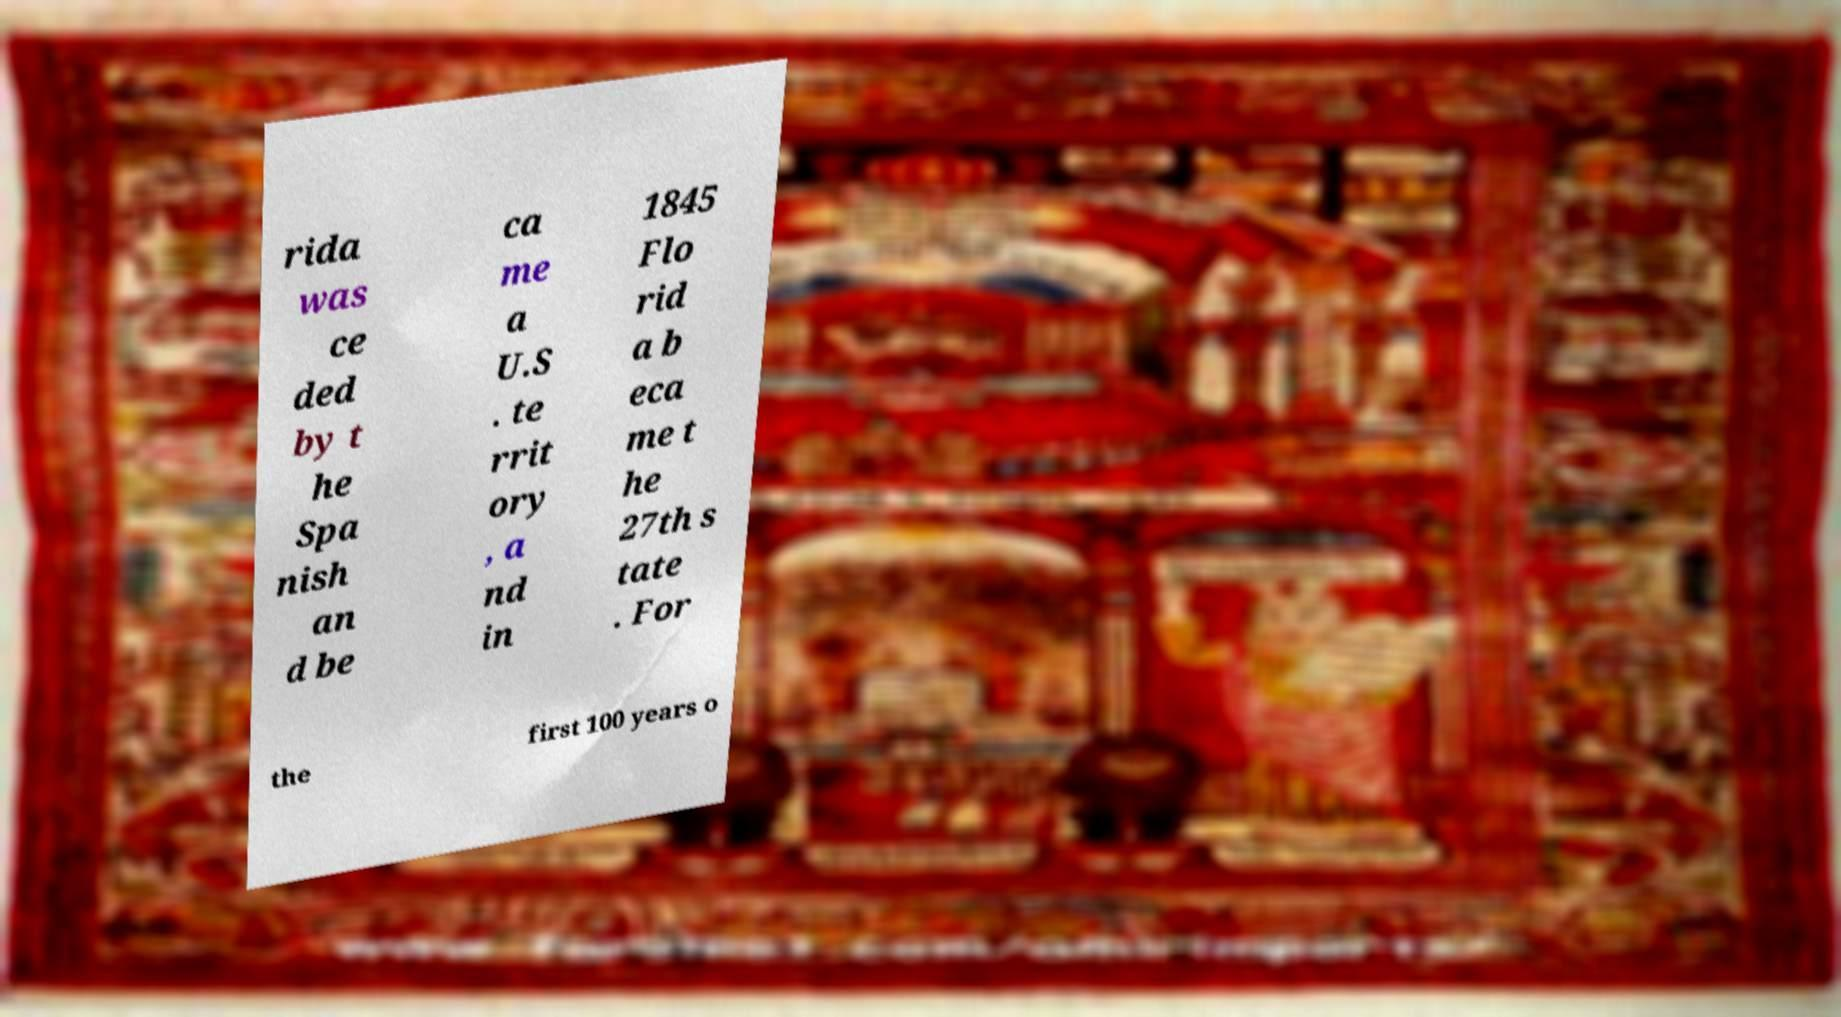For documentation purposes, I need the text within this image transcribed. Could you provide that? rida was ce ded by t he Spa nish an d be ca me a U.S . te rrit ory , a nd in 1845 Flo rid a b eca me t he 27th s tate . For the first 100 years o 